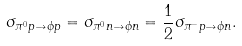<formula> <loc_0><loc_0><loc_500><loc_500>\sigma _ { { \pi } ^ { 0 } p \to { \phi } p } = \sigma _ { { \pi } ^ { 0 } n \to { \phi } n } = \frac { 1 } { 2 } \sigma _ { { \pi } ^ { - } p \to { \phi } n } .</formula> 